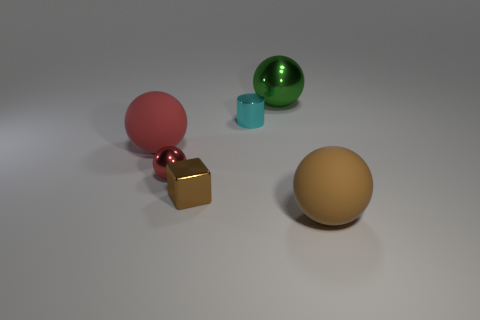Add 2 big things. How many objects exist? 8 Subtract all cylinders. How many objects are left? 5 Subtract all brown balls. Subtract all brown balls. How many objects are left? 4 Add 5 small red balls. How many small red balls are left? 6 Add 3 cyan metal objects. How many cyan metal objects exist? 4 Subtract 0 yellow cylinders. How many objects are left? 6 